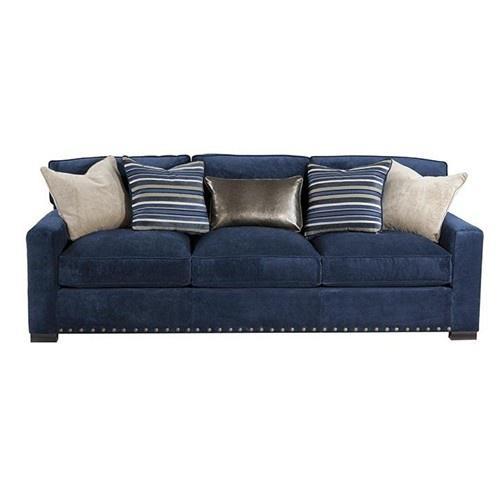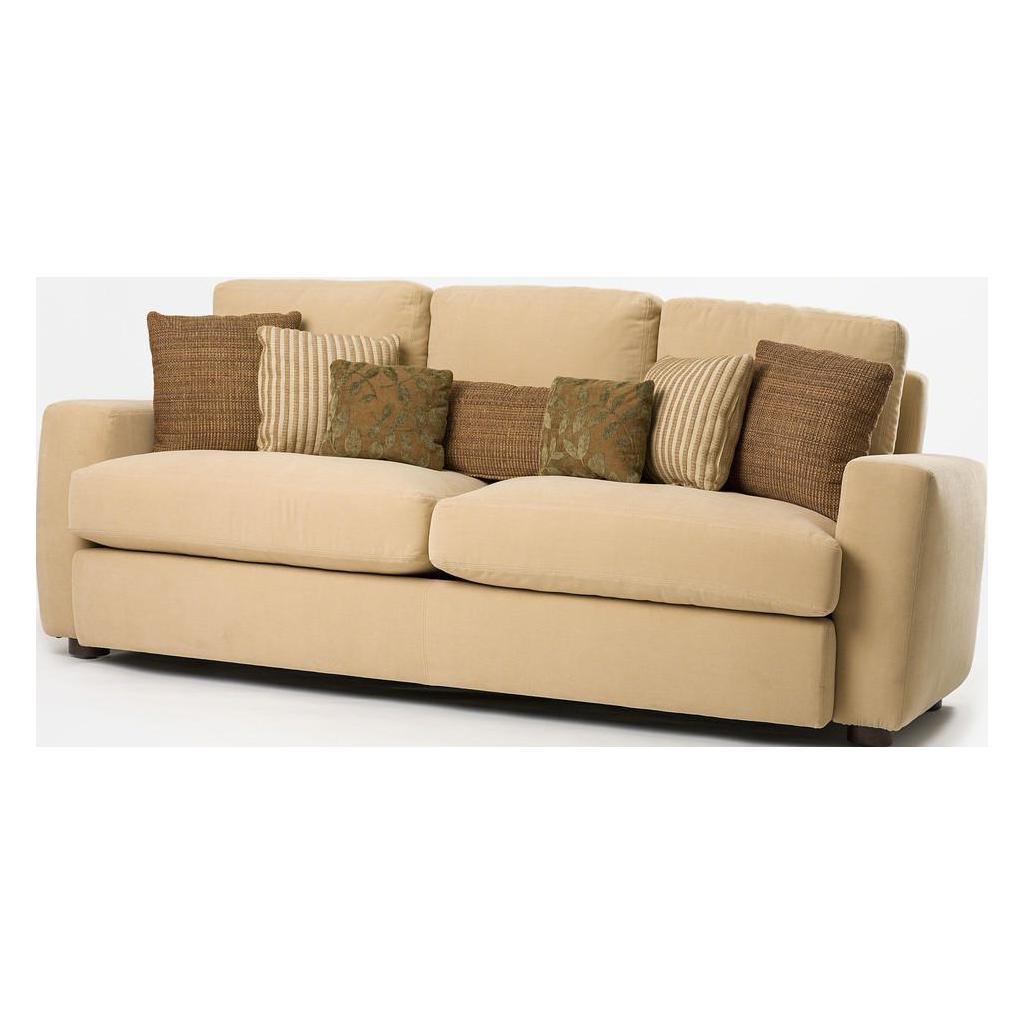The first image is the image on the left, the second image is the image on the right. Given the left and right images, does the statement "One of the images shows a sectional sofa with an attached ottoman." hold true? Answer yes or no. No. The first image is the image on the left, the second image is the image on the right. For the images shown, is this caption "There are a total of 8 throw pillows." true? Answer yes or no. No. 